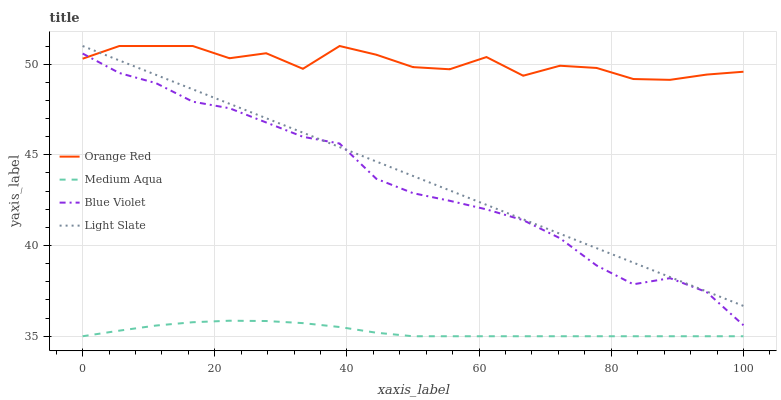Does Medium Aqua have the minimum area under the curve?
Answer yes or no. Yes. Does Orange Red have the maximum area under the curve?
Answer yes or no. Yes. Does Orange Red have the minimum area under the curve?
Answer yes or no. No. Does Medium Aqua have the maximum area under the curve?
Answer yes or no. No. Is Light Slate the smoothest?
Answer yes or no. Yes. Is Orange Red the roughest?
Answer yes or no. Yes. Is Medium Aqua the smoothest?
Answer yes or no. No. Is Medium Aqua the roughest?
Answer yes or no. No. Does Medium Aqua have the lowest value?
Answer yes or no. Yes. Does Orange Red have the lowest value?
Answer yes or no. No. Does Orange Red have the highest value?
Answer yes or no. Yes. Does Medium Aqua have the highest value?
Answer yes or no. No. Is Medium Aqua less than Orange Red?
Answer yes or no. Yes. Is Light Slate greater than Medium Aqua?
Answer yes or no. Yes. Does Light Slate intersect Blue Violet?
Answer yes or no. Yes. Is Light Slate less than Blue Violet?
Answer yes or no. No. Is Light Slate greater than Blue Violet?
Answer yes or no. No. Does Medium Aqua intersect Orange Red?
Answer yes or no. No. 